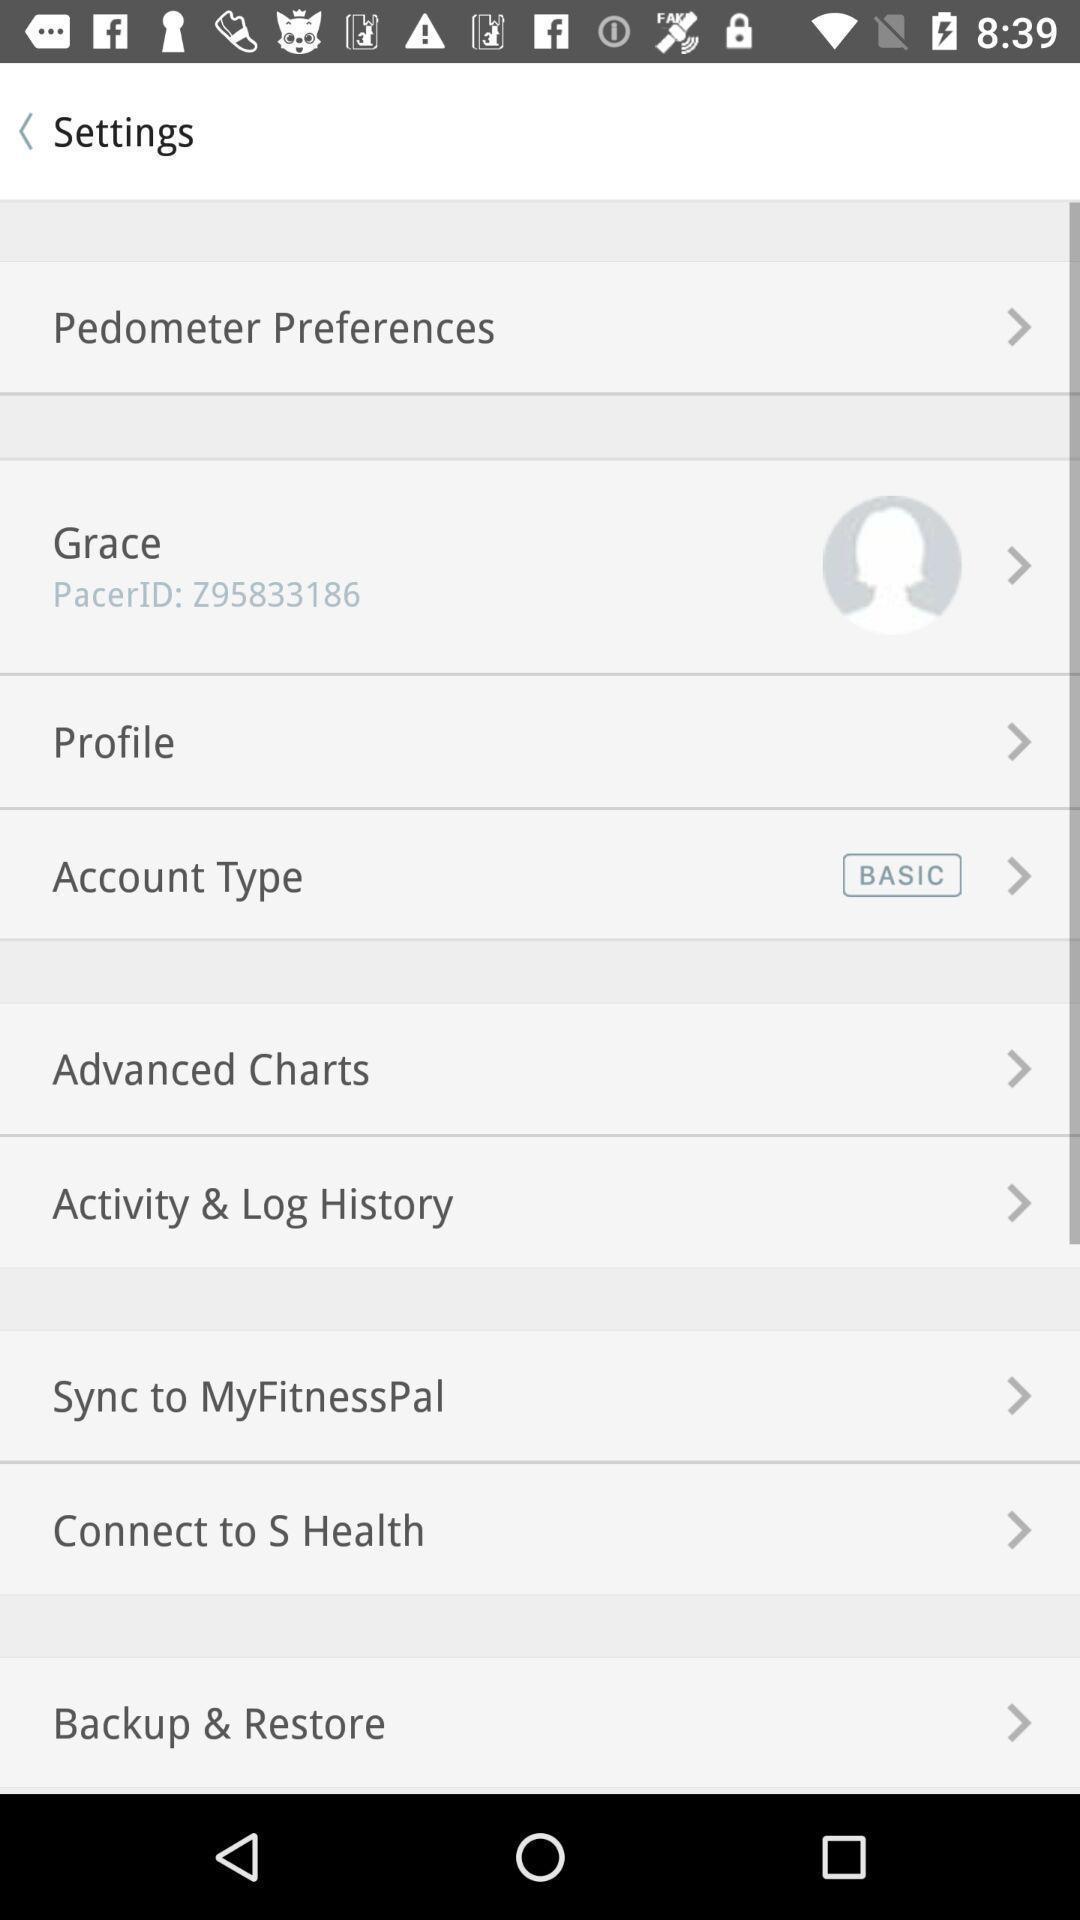Explain the elements present in this screenshot. Settings page of steps counting application. 